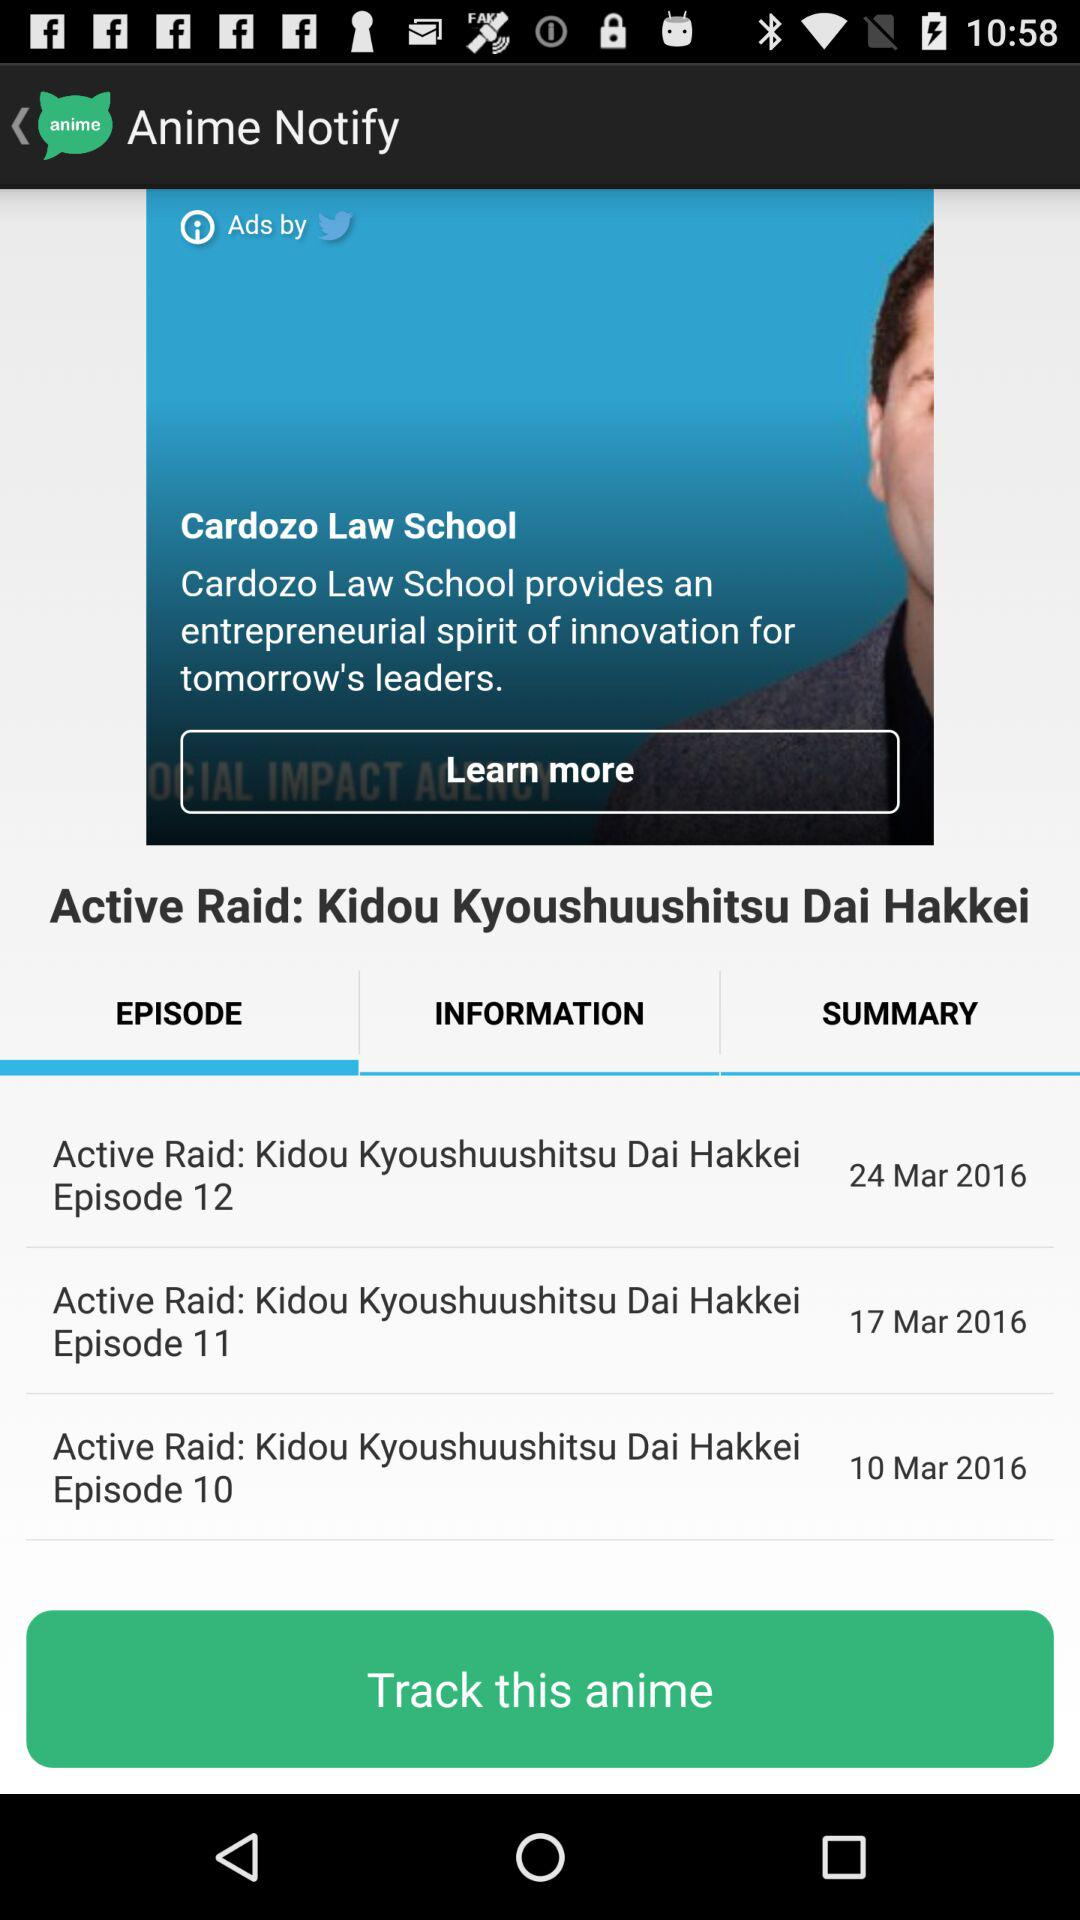When was episode 11 posted? Episode 11 was posted on March 17, 2016. 